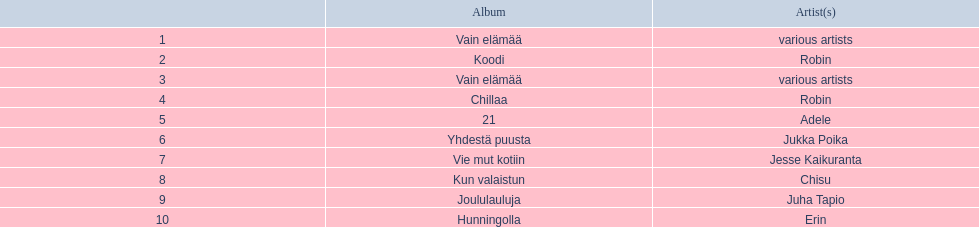What sales does adele have? 44,297. What sales does chisu have? 31,541. Which of these numbers are higher? 44,297. Who has this number of sales? Adele. 